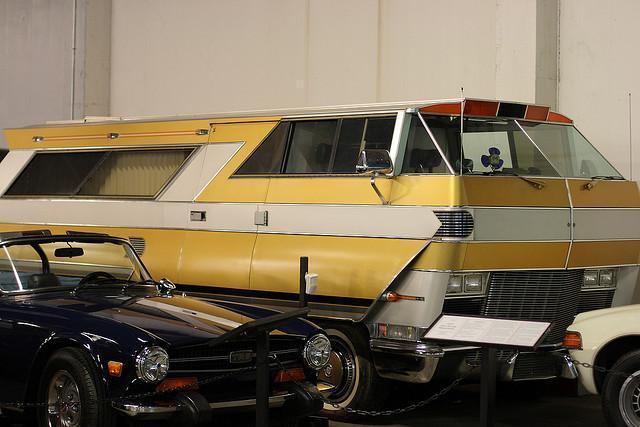How many cars can be seen?
Give a very brief answer. 2. How many elephants have tusks?
Give a very brief answer. 0. 